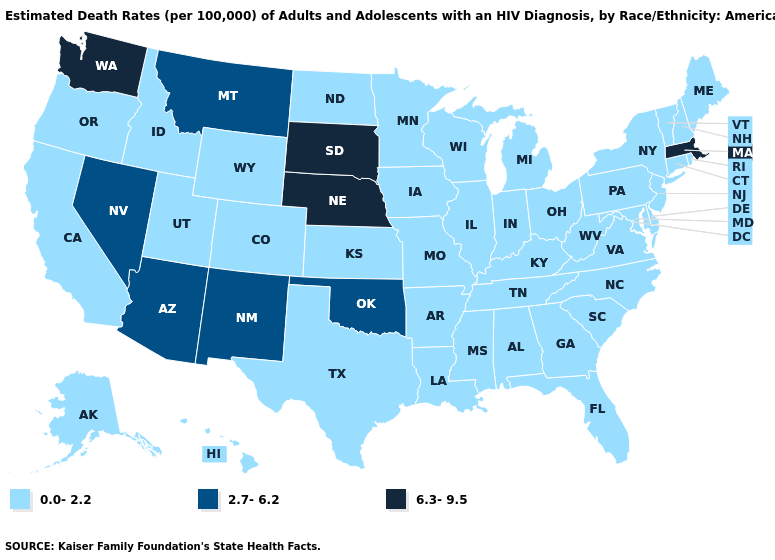Is the legend a continuous bar?
Be succinct. No. Name the states that have a value in the range 2.7-6.2?
Keep it brief. Arizona, Montana, Nevada, New Mexico, Oklahoma. Name the states that have a value in the range 2.7-6.2?
Give a very brief answer. Arizona, Montana, Nevada, New Mexico, Oklahoma. Does Washington have the highest value in the USA?
Write a very short answer. Yes. Name the states that have a value in the range 6.3-9.5?
Give a very brief answer. Massachusetts, Nebraska, South Dakota, Washington. Does Washington have the highest value in the West?
Short answer required. Yes. Among the states that border Idaho , which have the highest value?
Answer briefly. Washington. What is the highest value in states that border Maryland?
Answer briefly. 0.0-2.2. Among the states that border Connecticut , does Rhode Island have the highest value?
Write a very short answer. No. Does Massachusetts have the lowest value in the USA?
Short answer required. No. Which states have the highest value in the USA?
Concise answer only. Massachusetts, Nebraska, South Dakota, Washington. Does Mississippi have the same value as Kansas?
Short answer required. Yes. Does Massachusetts have a higher value than Wisconsin?
Concise answer only. Yes. What is the lowest value in states that border Michigan?
Be succinct. 0.0-2.2. 